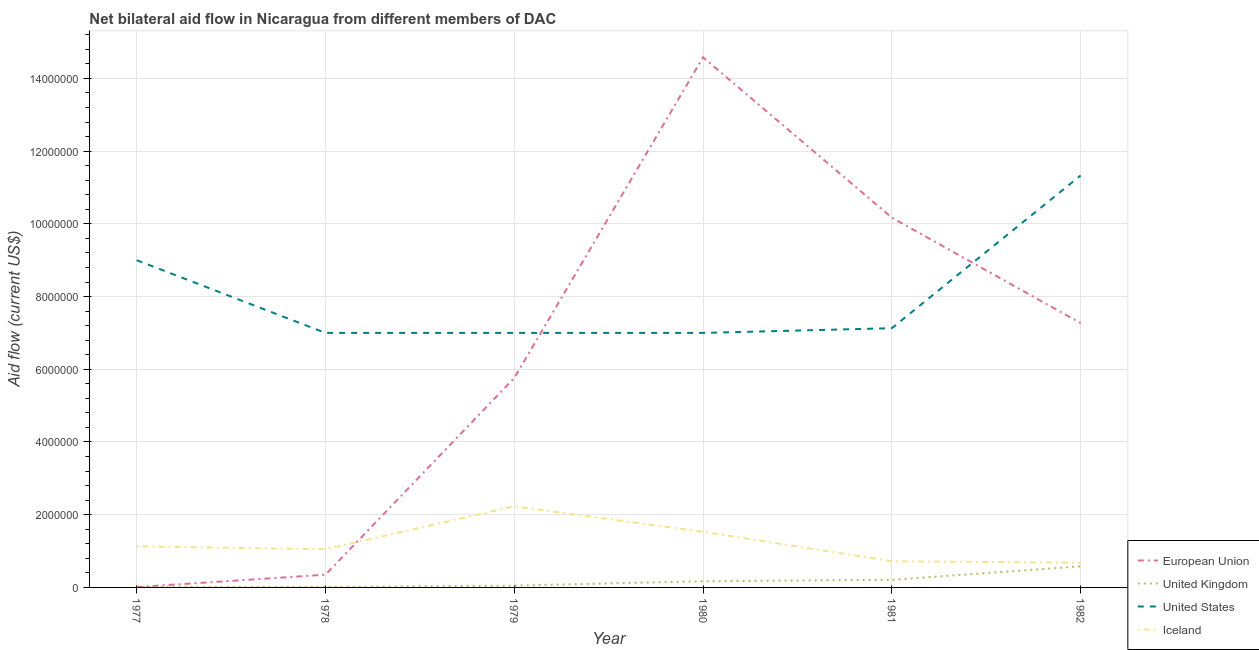How many different coloured lines are there?
Offer a terse response. 4. Does the line corresponding to amount of aid given by eu intersect with the line corresponding to amount of aid given by iceland?
Offer a terse response. Yes. Is the number of lines equal to the number of legend labels?
Provide a succinct answer. Yes. What is the amount of aid given by eu in 1978?
Make the answer very short. 3.50e+05. Across all years, what is the maximum amount of aid given by us?
Offer a terse response. 1.13e+07. Across all years, what is the minimum amount of aid given by iceland?
Offer a terse response. 6.80e+05. In which year was the amount of aid given by us minimum?
Your answer should be very brief. 1978. What is the total amount of aid given by uk in the graph?
Keep it short and to the point. 1.03e+06. What is the difference between the amount of aid given by us in 1978 and that in 1979?
Ensure brevity in your answer.  0. What is the difference between the amount of aid given by eu in 1981 and the amount of aid given by uk in 1982?
Provide a short and direct response. 9.59e+06. What is the average amount of aid given by eu per year?
Offer a terse response. 6.36e+06. What is the ratio of the amount of aid given by uk in 1977 to that in 1982?
Provide a succinct answer. 0.02. Is the amount of aid given by iceland in 1978 less than that in 1979?
Provide a short and direct response. Yes. Is the difference between the amount of aid given by uk in 1980 and 1982 greater than the difference between the amount of aid given by eu in 1980 and 1982?
Your answer should be compact. No. What is the difference between the highest and the second highest amount of aid given by us?
Give a very brief answer. 2.33e+06. What is the difference between the highest and the lowest amount of aid given by eu?
Ensure brevity in your answer.  1.46e+07. In how many years, is the amount of aid given by uk greater than the average amount of aid given by uk taken over all years?
Provide a succinct answer. 2. Is it the case that in every year, the sum of the amount of aid given by iceland and amount of aid given by us is greater than the sum of amount of aid given by eu and amount of aid given by uk?
Provide a short and direct response. No. Is the amount of aid given by us strictly less than the amount of aid given by eu over the years?
Ensure brevity in your answer.  No. How many lines are there?
Offer a very short reply. 4. What is the difference between two consecutive major ticks on the Y-axis?
Offer a terse response. 2.00e+06. Does the graph contain any zero values?
Ensure brevity in your answer.  No. Does the graph contain grids?
Provide a short and direct response. Yes. What is the title of the graph?
Offer a very short reply. Net bilateral aid flow in Nicaragua from different members of DAC. What is the Aid flow (current US$) of European Union in 1977?
Make the answer very short. 10000. What is the Aid flow (current US$) in United States in 1977?
Your response must be concise. 9.00e+06. What is the Aid flow (current US$) of Iceland in 1977?
Ensure brevity in your answer.  1.13e+06. What is the Aid flow (current US$) of European Union in 1978?
Keep it short and to the point. 3.50e+05. What is the Aid flow (current US$) in Iceland in 1978?
Make the answer very short. 1.05e+06. What is the Aid flow (current US$) in European Union in 1979?
Your response must be concise. 5.76e+06. What is the Aid flow (current US$) of United States in 1979?
Provide a short and direct response. 7.00e+06. What is the Aid flow (current US$) of Iceland in 1979?
Your answer should be very brief. 2.23e+06. What is the Aid flow (current US$) in European Union in 1980?
Ensure brevity in your answer.  1.46e+07. What is the Aid flow (current US$) in United Kingdom in 1980?
Ensure brevity in your answer.  1.70e+05. What is the Aid flow (current US$) of United States in 1980?
Offer a very short reply. 7.00e+06. What is the Aid flow (current US$) in Iceland in 1980?
Make the answer very short. 1.53e+06. What is the Aid flow (current US$) of European Union in 1981?
Offer a terse response. 1.02e+07. What is the Aid flow (current US$) in United States in 1981?
Offer a terse response. 7.13e+06. What is the Aid flow (current US$) in Iceland in 1981?
Make the answer very short. 7.20e+05. What is the Aid flow (current US$) of European Union in 1982?
Provide a succinct answer. 7.27e+06. What is the Aid flow (current US$) of United Kingdom in 1982?
Your response must be concise. 5.80e+05. What is the Aid flow (current US$) of United States in 1982?
Your response must be concise. 1.13e+07. What is the Aid flow (current US$) in Iceland in 1982?
Ensure brevity in your answer.  6.80e+05. Across all years, what is the maximum Aid flow (current US$) of European Union?
Your answer should be compact. 1.46e+07. Across all years, what is the maximum Aid flow (current US$) in United Kingdom?
Provide a short and direct response. 5.80e+05. Across all years, what is the maximum Aid flow (current US$) of United States?
Provide a short and direct response. 1.13e+07. Across all years, what is the maximum Aid flow (current US$) in Iceland?
Make the answer very short. 2.23e+06. Across all years, what is the minimum Aid flow (current US$) of United States?
Your answer should be very brief. 7.00e+06. Across all years, what is the minimum Aid flow (current US$) of Iceland?
Keep it short and to the point. 6.80e+05. What is the total Aid flow (current US$) of European Union in the graph?
Your response must be concise. 3.81e+07. What is the total Aid flow (current US$) in United Kingdom in the graph?
Give a very brief answer. 1.03e+06. What is the total Aid flow (current US$) of United States in the graph?
Give a very brief answer. 4.85e+07. What is the total Aid flow (current US$) in Iceland in the graph?
Offer a very short reply. 7.34e+06. What is the difference between the Aid flow (current US$) of European Union in 1977 and that in 1978?
Give a very brief answer. -3.40e+05. What is the difference between the Aid flow (current US$) of United Kingdom in 1977 and that in 1978?
Your answer should be compact. 0. What is the difference between the Aid flow (current US$) of United States in 1977 and that in 1978?
Make the answer very short. 2.00e+06. What is the difference between the Aid flow (current US$) of Iceland in 1977 and that in 1978?
Provide a succinct answer. 8.00e+04. What is the difference between the Aid flow (current US$) in European Union in 1977 and that in 1979?
Provide a short and direct response. -5.75e+06. What is the difference between the Aid flow (current US$) in Iceland in 1977 and that in 1979?
Give a very brief answer. -1.10e+06. What is the difference between the Aid flow (current US$) of European Union in 1977 and that in 1980?
Your response must be concise. -1.46e+07. What is the difference between the Aid flow (current US$) in United Kingdom in 1977 and that in 1980?
Your answer should be very brief. -1.60e+05. What is the difference between the Aid flow (current US$) in Iceland in 1977 and that in 1980?
Ensure brevity in your answer.  -4.00e+05. What is the difference between the Aid flow (current US$) of European Union in 1977 and that in 1981?
Ensure brevity in your answer.  -1.02e+07. What is the difference between the Aid flow (current US$) in United Kingdom in 1977 and that in 1981?
Provide a succinct answer. -2.00e+05. What is the difference between the Aid flow (current US$) of United States in 1977 and that in 1981?
Your response must be concise. 1.87e+06. What is the difference between the Aid flow (current US$) in European Union in 1977 and that in 1982?
Offer a very short reply. -7.26e+06. What is the difference between the Aid flow (current US$) of United Kingdom in 1977 and that in 1982?
Offer a terse response. -5.70e+05. What is the difference between the Aid flow (current US$) of United States in 1977 and that in 1982?
Provide a short and direct response. -2.33e+06. What is the difference between the Aid flow (current US$) of Iceland in 1977 and that in 1982?
Make the answer very short. 4.50e+05. What is the difference between the Aid flow (current US$) in European Union in 1978 and that in 1979?
Your answer should be compact. -5.41e+06. What is the difference between the Aid flow (current US$) of United Kingdom in 1978 and that in 1979?
Keep it short and to the point. -4.00e+04. What is the difference between the Aid flow (current US$) in Iceland in 1978 and that in 1979?
Your response must be concise. -1.18e+06. What is the difference between the Aid flow (current US$) in European Union in 1978 and that in 1980?
Your response must be concise. -1.42e+07. What is the difference between the Aid flow (current US$) in United Kingdom in 1978 and that in 1980?
Offer a very short reply. -1.60e+05. What is the difference between the Aid flow (current US$) of Iceland in 1978 and that in 1980?
Give a very brief answer. -4.80e+05. What is the difference between the Aid flow (current US$) in European Union in 1978 and that in 1981?
Ensure brevity in your answer.  -9.82e+06. What is the difference between the Aid flow (current US$) of European Union in 1978 and that in 1982?
Your response must be concise. -6.92e+06. What is the difference between the Aid flow (current US$) in United Kingdom in 1978 and that in 1982?
Make the answer very short. -5.70e+05. What is the difference between the Aid flow (current US$) in United States in 1978 and that in 1982?
Your answer should be very brief. -4.33e+06. What is the difference between the Aid flow (current US$) of Iceland in 1978 and that in 1982?
Your answer should be very brief. 3.70e+05. What is the difference between the Aid flow (current US$) in European Union in 1979 and that in 1980?
Your answer should be very brief. -8.82e+06. What is the difference between the Aid flow (current US$) in European Union in 1979 and that in 1981?
Keep it short and to the point. -4.41e+06. What is the difference between the Aid flow (current US$) of Iceland in 1979 and that in 1981?
Provide a succinct answer. 1.51e+06. What is the difference between the Aid flow (current US$) in European Union in 1979 and that in 1982?
Your response must be concise. -1.51e+06. What is the difference between the Aid flow (current US$) of United Kingdom in 1979 and that in 1982?
Provide a short and direct response. -5.30e+05. What is the difference between the Aid flow (current US$) of United States in 1979 and that in 1982?
Keep it short and to the point. -4.33e+06. What is the difference between the Aid flow (current US$) of Iceland in 1979 and that in 1982?
Give a very brief answer. 1.55e+06. What is the difference between the Aid flow (current US$) of European Union in 1980 and that in 1981?
Your answer should be compact. 4.41e+06. What is the difference between the Aid flow (current US$) of United States in 1980 and that in 1981?
Offer a very short reply. -1.30e+05. What is the difference between the Aid flow (current US$) of Iceland in 1980 and that in 1981?
Offer a terse response. 8.10e+05. What is the difference between the Aid flow (current US$) in European Union in 1980 and that in 1982?
Provide a succinct answer. 7.31e+06. What is the difference between the Aid flow (current US$) in United Kingdom in 1980 and that in 1982?
Provide a short and direct response. -4.10e+05. What is the difference between the Aid flow (current US$) in United States in 1980 and that in 1982?
Provide a succinct answer. -4.33e+06. What is the difference between the Aid flow (current US$) of Iceland in 1980 and that in 1982?
Provide a succinct answer. 8.50e+05. What is the difference between the Aid flow (current US$) of European Union in 1981 and that in 1982?
Offer a very short reply. 2.90e+06. What is the difference between the Aid flow (current US$) in United Kingdom in 1981 and that in 1982?
Your answer should be compact. -3.70e+05. What is the difference between the Aid flow (current US$) in United States in 1981 and that in 1982?
Keep it short and to the point. -4.20e+06. What is the difference between the Aid flow (current US$) of European Union in 1977 and the Aid flow (current US$) of United States in 1978?
Provide a short and direct response. -6.99e+06. What is the difference between the Aid flow (current US$) of European Union in 1977 and the Aid flow (current US$) of Iceland in 1978?
Keep it short and to the point. -1.04e+06. What is the difference between the Aid flow (current US$) in United Kingdom in 1977 and the Aid flow (current US$) in United States in 1978?
Provide a succinct answer. -6.99e+06. What is the difference between the Aid flow (current US$) of United Kingdom in 1977 and the Aid flow (current US$) of Iceland in 1978?
Your response must be concise. -1.04e+06. What is the difference between the Aid flow (current US$) in United States in 1977 and the Aid flow (current US$) in Iceland in 1978?
Offer a very short reply. 7.95e+06. What is the difference between the Aid flow (current US$) of European Union in 1977 and the Aid flow (current US$) of United States in 1979?
Provide a short and direct response. -6.99e+06. What is the difference between the Aid flow (current US$) in European Union in 1977 and the Aid flow (current US$) in Iceland in 1979?
Provide a succinct answer. -2.22e+06. What is the difference between the Aid flow (current US$) in United Kingdom in 1977 and the Aid flow (current US$) in United States in 1979?
Give a very brief answer. -6.99e+06. What is the difference between the Aid flow (current US$) of United Kingdom in 1977 and the Aid flow (current US$) of Iceland in 1979?
Offer a terse response. -2.22e+06. What is the difference between the Aid flow (current US$) of United States in 1977 and the Aid flow (current US$) of Iceland in 1979?
Keep it short and to the point. 6.77e+06. What is the difference between the Aid flow (current US$) of European Union in 1977 and the Aid flow (current US$) of United Kingdom in 1980?
Your answer should be compact. -1.60e+05. What is the difference between the Aid flow (current US$) in European Union in 1977 and the Aid flow (current US$) in United States in 1980?
Your answer should be compact. -6.99e+06. What is the difference between the Aid flow (current US$) in European Union in 1977 and the Aid flow (current US$) in Iceland in 1980?
Your answer should be very brief. -1.52e+06. What is the difference between the Aid flow (current US$) in United Kingdom in 1977 and the Aid flow (current US$) in United States in 1980?
Provide a succinct answer. -6.99e+06. What is the difference between the Aid flow (current US$) of United Kingdom in 1977 and the Aid flow (current US$) of Iceland in 1980?
Your answer should be compact. -1.52e+06. What is the difference between the Aid flow (current US$) in United States in 1977 and the Aid flow (current US$) in Iceland in 1980?
Offer a terse response. 7.47e+06. What is the difference between the Aid flow (current US$) in European Union in 1977 and the Aid flow (current US$) in United States in 1981?
Offer a terse response. -7.12e+06. What is the difference between the Aid flow (current US$) of European Union in 1977 and the Aid flow (current US$) of Iceland in 1981?
Offer a very short reply. -7.10e+05. What is the difference between the Aid flow (current US$) in United Kingdom in 1977 and the Aid flow (current US$) in United States in 1981?
Provide a succinct answer. -7.12e+06. What is the difference between the Aid flow (current US$) in United Kingdom in 1977 and the Aid flow (current US$) in Iceland in 1981?
Ensure brevity in your answer.  -7.10e+05. What is the difference between the Aid flow (current US$) of United States in 1977 and the Aid flow (current US$) of Iceland in 1981?
Provide a short and direct response. 8.28e+06. What is the difference between the Aid flow (current US$) in European Union in 1977 and the Aid flow (current US$) in United Kingdom in 1982?
Keep it short and to the point. -5.70e+05. What is the difference between the Aid flow (current US$) of European Union in 1977 and the Aid flow (current US$) of United States in 1982?
Give a very brief answer. -1.13e+07. What is the difference between the Aid flow (current US$) of European Union in 1977 and the Aid flow (current US$) of Iceland in 1982?
Your response must be concise. -6.70e+05. What is the difference between the Aid flow (current US$) of United Kingdom in 1977 and the Aid flow (current US$) of United States in 1982?
Ensure brevity in your answer.  -1.13e+07. What is the difference between the Aid flow (current US$) of United Kingdom in 1977 and the Aid flow (current US$) of Iceland in 1982?
Your answer should be very brief. -6.70e+05. What is the difference between the Aid flow (current US$) of United States in 1977 and the Aid flow (current US$) of Iceland in 1982?
Ensure brevity in your answer.  8.32e+06. What is the difference between the Aid flow (current US$) of European Union in 1978 and the Aid flow (current US$) of United Kingdom in 1979?
Provide a succinct answer. 3.00e+05. What is the difference between the Aid flow (current US$) in European Union in 1978 and the Aid flow (current US$) in United States in 1979?
Offer a terse response. -6.65e+06. What is the difference between the Aid flow (current US$) in European Union in 1978 and the Aid flow (current US$) in Iceland in 1979?
Your answer should be compact. -1.88e+06. What is the difference between the Aid flow (current US$) in United Kingdom in 1978 and the Aid flow (current US$) in United States in 1979?
Provide a succinct answer. -6.99e+06. What is the difference between the Aid flow (current US$) in United Kingdom in 1978 and the Aid flow (current US$) in Iceland in 1979?
Provide a succinct answer. -2.22e+06. What is the difference between the Aid flow (current US$) in United States in 1978 and the Aid flow (current US$) in Iceland in 1979?
Your answer should be compact. 4.77e+06. What is the difference between the Aid flow (current US$) in European Union in 1978 and the Aid flow (current US$) in United Kingdom in 1980?
Keep it short and to the point. 1.80e+05. What is the difference between the Aid flow (current US$) in European Union in 1978 and the Aid flow (current US$) in United States in 1980?
Offer a terse response. -6.65e+06. What is the difference between the Aid flow (current US$) of European Union in 1978 and the Aid flow (current US$) of Iceland in 1980?
Provide a short and direct response. -1.18e+06. What is the difference between the Aid flow (current US$) in United Kingdom in 1978 and the Aid flow (current US$) in United States in 1980?
Ensure brevity in your answer.  -6.99e+06. What is the difference between the Aid flow (current US$) of United Kingdom in 1978 and the Aid flow (current US$) of Iceland in 1980?
Your answer should be compact. -1.52e+06. What is the difference between the Aid flow (current US$) of United States in 1978 and the Aid flow (current US$) of Iceland in 1980?
Ensure brevity in your answer.  5.47e+06. What is the difference between the Aid flow (current US$) in European Union in 1978 and the Aid flow (current US$) in United Kingdom in 1981?
Make the answer very short. 1.40e+05. What is the difference between the Aid flow (current US$) of European Union in 1978 and the Aid flow (current US$) of United States in 1981?
Provide a short and direct response. -6.78e+06. What is the difference between the Aid flow (current US$) of European Union in 1978 and the Aid flow (current US$) of Iceland in 1981?
Your response must be concise. -3.70e+05. What is the difference between the Aid flow (current US$) of United Kingdom in 1978 and the Aid flow (current US$) of United States in 1981?
Your answer should be compact. -7.12e+06. What is the difference between the Aid flow (current US$) in United Kingdom in 1978 and the Aid flow (current US$) in Iceland in 1981?
Make the answer very short. -7.10e+05. What is the difference between the Aid flow (current US$) of United States in 1978 and the Aid flow (current US$) of Iceland in 1981?
Keep it short and to the point. 6.28e+06. What is the difference between the Aid flow (current US$) in European Union in 1978 and the Aid flow (current US$) in United States in 1982?
Your answer should be compact. -1.10e+07. What is the difference between the Aid flow (current US$) in European Union in 1978 and the Aid flow (current US$) in Iceland in 1982?
Offer a terse response. -3.30e+05. What is the difference between the Aid flow (current US$) of United Kingdom in 1978 and the Aid flow (current US$) of United States in 1982?
Ensure brevity in your answer.  -1.13e+07. What is the difference between the Aid flow (current US$) in United Kingdom in 1978 and the Aid flow (current US$) in Iceland in 1982?
Offer a terse response. -6.70e+05. What is the difference between the Aid flow (current US$) of United States in 1978 and the Aid flow (current US$) of Iceland in 1982?
Make the answer very short. 6.32e+06. What is the difference between the Aid flow (current US$) in European Union in 1979 and the Aid flow (current US$) in United Kingdom in 1980?
Provide a succinct answer. 5.59e+06. What is the difference between the Aid flow (current US$) of European Union in 1979 and the Aid flow (current US$) of United States in 1980?
Make the answer very short. -1.24e+06. What is the difference between the Aid flow (current US$) in European Union in 1979 and the Aid flow (current US$) in Iceland in 1980?
Make the answer very short. 4.23e+06. What is the difference between the Aid flow (current US$) in United Kingdom in 1979 and the Aid flow (current US$) in United States in 1980?
Provide a short and direct response. -6.95e+06. What is the difference between the Aid flow (current US$) of United Kingdom in 1979 and the Aid flow (current US$) of Iceland in 1980?
Your response must be concise. -1.48e+06. What is the difference between the Aid flow (current US$) of United States in 1979 and the Aid flow (current US$) of Iceland in 1980?
Offer a very short reply. 5.47e+06. What is the difference between the Aid flow (current US$) in European Union in 1979 and the Aid flow (current US$) in United Kingdom in 1981?
Your response must be concise. 5.55e+06. What is the difference between the Aid flow (current US$) of European Union in 1979 and the Aid flow (current US$) of United States in 1981?
Provide a succinct answer. -1.37e+06. What is the difference between the Aid flow (current US$) in European Union in 1979 and the Aid flow (current US$) in Iceland in 1981?
Make the answer very short. 5.04e+06. What is the difference between the Aid flow (current US$) in United Kingdom in 1979 and the Aid flow (current US$) in United States in 1981?
Keep it short and to the point. -7.08e+06. What is the difference between the Aid flow (current US$) in United Kingdom in 1979 and the Aid flow (current US$) in Iceland in 1981?
Your response must be concise. -6.70e+05. What is the difference between the Aid flow (current US$) of United States in 1979 and the Aid flow (current US$) of Iceland in 1981?
Your response must be concise. 6.28e+06. What is the difference between the Aid flow (current US$) in European Union in 1979 and the Aid flow (current US$) in United Kingdom in 1982?
Offer a terse response. 5.18e+06. What is the difference between the Aid flow (current US$) of European Union in 1979 and the Aid flow (current US$) of United States in 1982?
Provide a succinct answer. -5.57e+06. What is the difference between the Aid flow (current US$) in European Union in 1979 and the Aid flow (current US$) in Iceland in 1982?
Give a very brief answer. 5.08e+06. What is the difference between the Aid flow (current US$) of United Kingdom in 1979 and the Aid flow (current US$) of United States in 1982?
Offer a terse response. -1.13e+07. What is the difference between the Aid flow (current US$) in United Kingdom in 1979 and the Aid flow (current US$) in Iceland in 1982?
Give a very brief answer. -6.30e+05. What is the difference between the Aid flow (current US$) of United States in 1979 and the Aid flow (current US$) of Iceland in 1982?
Ensure brevity in your answer.  6.32e+06. What is the difference between the Aid flow (current US$) in European Union in 1980 and the Aid flow (current US$) in United Kingdom in 1981?
Ensure brevity in your answer.  1.44e+07. What is the difference between the Aid flow (current US$) in European Union in 1980 and the Aid flow (current US$) in United States in 1981?
Provide a short and direct response. 7.45e+06. What is the difference between the Aid flow (current US$) of European Union in 1980 and the Aid flow (current US$) of Iceland in 1981?
Your answer should be compact. 1.39e+07. What is the difference between the Aid flow (current US$) of United Kingdom in 1980 and the Aid flow (current US$) of United States in 1981?
Ensure brevity in your answer.  -6.96e+06. What is the difference between the Aid flow (current US$) in United Kingdom in 1980 and the Aid flow (current US$) in Iceland in 1981?
Keep it short and to the point. -5.50e+05. What is the difference between the Aid flow (current US$) in United States in 1980 and the Aid flow (current US$) in Iceland in 1981?
Keep it short and to the point. 6.28e+06. What is the difference between the Aid flow (current US$) in European Union in 1980 and the Aid flow (current US$) in United Kingdom in 1982?
Ensure brevity in your answer.  1.40e+07. What is the difference between the Aid flow (current US$) of European Union in 1980 and the Aid flow (current US$) of United States in 1982?
Your answer should be compact. 3.25e+06. What is the difference between the Aid flow (current US$) of European Union in 1980 and the Aid flow (current US$) of Iceland in 1982?
Your response must be concise. 1.39e+07. What is the difference between the Aid flow (current US$) in United Kingdom in 1980 and the Aid flow (current US$) in United States in 1982?
Make the answer very short. -1.12e+07. What is the difference between the Aid flow (current US$) of United Kingdom in 1980 and the Aid flow (current US$) of Iceland in 1982?
Your answer should be very brief. -5.10e+05. What is the difference between the Aid flow (current US$) in United States in 1980 and the Aid flow (current US$) in Iceland in 1982?
Provide a short and direct response. 6.32e+06. What is the difference between the Aid flow (current US$) in European Union in 1981 and the Aid flow (current US$) in United Kingdom in 1982?
Your answer should be very brief. 9.59e+06. What is the difference between the Aid flow (current US$) of European Union in 1981 and the Aid flow (current US$) of United States in 1982?
Ensure brevity in your answer.  -1.16e+06. What is the difference between the Aid flow (current US$) of European Union in 1981 and the Aid flow (current US$) of Iceland in 1982?
Make the answer very short. 9.49e+06. What is the difference between the Aid flow (current US$) of United Kingdom in 1981 and the Aid flow (current US$) of United States in 1982?
Your answer should be compact. -1.11e+07. What is the difference between the Aid flow (current US$) in United Kingdom in 1981 and the Aid flow (current US$) in Iceland in 1982?
Provide a succinct answer. -4.70e+05. What is the difference between the Aid flow (current US$) in United States in 1981 and the Aid flow (current US$) in Iceland in 1982?
Your answer should be very brief. 6.45e+06. What is the average Aid flow (current US$) in European Union per year?
Give a very brief answer. 6.36e+06. What is the average Aid flow (current US$) of United Kingdom per year?
Your answer should be very brief. 1.72e+05. What is the average Aid flow (current US$) in United States per year?
Offer a terse response. 8.08e+06. What is the average Aid flow (current US$) in Iceland per year?
Make the answer very short. 1.22e+06. In the year 1977, what is the difference between the Aid flow (current US$) in European Union and Aid flow (current US$) in United States?
Keep it short and to the point. -8.99e+06. In the year 1977, what is the difference between the Aid flow (current US$) in European Union and Aid flow (current US$) in Iceland?
Give a very brief answer. -1.12e+06. In the year 1977, what is the difference between the Aid flow (current US$) in United Kingdom and Aid flow (current US$) in United States?
Make the answer very short. -8.99e+06. In the year 1977, what is the difference between the Aid flow (current US$) in United Kingdom and Aid flow (current US$) in Iceland?
Offer a very short reply. -1.12e+06. In the year 1977, what is the difference between the Aid flow (current US$) of United States and Aid flow (current US$) of Iceland?
Your answer should be very brief. 7.87e+06. In the year 1978, what is the difference between the Aid flow (current US$) of European Union and Aid flow (current US$) of United Kingdom?
Provide a short and direct response. 3.40e+05. In the year 1978, what is the difference between the Aid flow (current US$) of European Union and Aid flow (current US$) of United States?
Your answer should be compact. -6.65e+06. In the year 1978, what is the difference between the Aid flow (current US$) in European Union and Aid flow (current US$) in Iceland?
Offer a very short reply. -7.00e+05. In the year 1978, what is the difference between the Aid flow (current US$) of United Kingdom and Aid flow (current US$) of United States?
Your answer should be compact. -6.99e+06. In the year 1978, what is the difference between the Aid flow (current US$) of United Kingdom and Aid flow (current US$) of Iceland?
Your response must be concise. -1.04e+06. In the year 1978, what is the difference between the Aid flow (current US$) of United States and Aid flow (current US$) of Iceland?
Provide a succinct answer. 5.95e+06. In the year 1979, what is the difference between the Aid flow (current US$) of European Union and Aid flow (current US$) of United Kingdom?
Offer a terse response. 5.71e+06. In the year 1979, what is the difference between the Aid flow (current US$) in European Union and Aid flow (current US$) in United States?
Provide a short and direct response. -1.24e+06. In the year 1979, what is the difference between the Aid flow (current US$) of European Union and Aid flow (current US$) of Iceland?
Offer a terse response. 3.53e+06. In the year 1979, what is the difference between the Aid flow (current US$) in United Kingdom and Aid flow (current US$) in United States?
Give a very brief answer. -6.95e+06. In the year 1979, what is the difference between the Aid flow (current US$) in United Kingdom and Aid flow (current US$) in Iceland?
Your response must be concise. -2.18e+06. In the year 1979, what is the difference between the Aid flow (current US$) of United States and Aid flow (current US$) of Iceland?
Your answer should be compact. 4.77e+06. In the year 1980, what is the difference between the Aid flow (current US$) in European Union and Aid flow (current US$) in United Kingdom?
Keep it short and to the point. 1.44e+07. In the year 1980, what is the difference between the Aid flow (current US$) in European Union and Aid flow (current US$) in United States?
Your response must be concise. 7.58e+06. In the year 1980, what is the difference between the Aid flow (current US$) of European Union and Aid flow (current US$) of Iceland?
Give a very brief answer. 1.30e+07. In the year 1980, what is the difference between the Aid flow (current US$) of United Kingdom and Aid flow (current US$) of United States?
Your answer should be very brief. -6.83e+06. In the year 1980, what is the difference between the Aid flow (current US$) of United Kingdom and Aid flow (current US$) of Iceland?
Your answer should be very brief. -1.36e+06. In the year 1980, what is the difference between the Aid flow (current US$) in United States and Aid flow (current US$) in Iceland?
Give a very brief answer. 5.47e+06. In the year 1981, what is the difference between the Aid flow (current US$) of European Union and Aid flow (current US$) of United Kingdom?
Give a very brief answer. 9.96e+06. In the year 1981, what is the difference between the Aid flow (current US$) in European Union and Aid flow (current US$) in United States?
Ensure brevity in your answer.  3.04e+06. In the year 1981, what is the difference between the Aid flow (current US$) of European Union and Aid flow (current US$) of Iceland?
Make the answer very short. 9.45e+06. In the year 1981, what is the difference between the Aid flow (current US$) in United Kingdom and Aid flow (current US$) in United States?
Your response must be concise. -6.92e+06. In the year 1981, what is the difference between the Aid flow (current US$) of United Kingdom and Aid flow (current US$) of Iceland?
Offer a very short reply. -5.10e+05. In the year 1981, what is the difference between the Aid flow (current US$) in United States and Aid flow (current US$) in Iceland?
Your answer should be very brief. 6.41e+06. In the year 1982, what is the difference between the Aid flow (current US$) in European Union and Aid flow (current US$) in United Kingdom?
Provide a short and direct response. 6.69e+06. In the year 1982, what is the difference between the Aid flow (current US$) of European Union and Aid flow (current US$) of United States?
Provide a succinct answer. -4.06e+06. In the year 1982, what is the difference between the Aid flow (current US$) of European Union and Aid flow (current US$) of Iceland?
Ensure brevity in your answer.  6.59e+06. In the year 1982, what is the difference between the Aid flow (current US$) of United Kingdom and Aid flow (current US$) of United States?
Offer a very short reply. -1.08e+07. In the year 1982, what is the difference between the Aid flow (current US$) in United States and Aid flow (current US$) in Iceland?
Your answer should be very brief. 1.06e+07. What is the ratio of the Aid flow (current US$) of European Union in 1977 to that in 1978?
Your answer should be very brief. 0.03. What is the ratio of the Aid flow (current US$) in Iceland in 1977 to that in 1978?
Offer a terse response. 1.08. What is the ratio of the Aid flow (current US$) in European Union in 1977 to that in 1979?
Give a very brief answer. 0. What is the ratio of the Aid flow (current US$) in United Kingdom in 1977 to that in 1979?
Your answer should be very brief. 0.2. What is the ratio of the Aid flow (current US$) in United States in 1977 to that in 1979?
Give a very brief answer. 1.29. What is the ratio of the Aid flow (current US$) in Iceland in 1977 to that in 1979?
Your answer should be very brief. 0.51. What is the ratio of the Aid flow (current US$) in European Union in 1977 to that in 1980?
Give a very brief answer. 0. What is the ratio of the Aid flow (current US$) of United Kingdom in 1977 to that in 1980?
Offer a very short reply. 0.06. What is the ratio of the Aid flow (current US$) in United States in 1977 to that in 1980?
Give a very brief answer. 1.29. What is the ratio of the Aid flow (current US$) in Iceland in 1977 to that in 1980?
Make the answer very short. 0.74. What is the ratio of the Aid flow (current US$) in United Kingdom in 1977 to that in 1981?
Ensure brevity in your answer.  0.05. What is the ratio of the Aid flow (current US$) of United States in 1977 to that in 1981?
Provide a short and direct response. 1.26. What is the ratio of the Aid flow (current US$) in Iceland in 1977 to that in 1981?
Your answer should be very brief. 1.57. What is the ratio of the Aid flow (current US$) in European Union in 1977 to that in 1982?
Offer a terse response. 0. What is the ratio of the Aid flow (current US$) in United Kingdom in 1977 to that in 1982?
Provide a succinct answer. 0.02. What is the ratio of the Aid flow (current US$) of United States in 1977 to that in 1982?
Provide a succinct answer. 0.79. What is the ratio of the Aid flow (current US$) of Iceland in 1977 to that in 1982?
Keep it short and to the point. 1.66. What is the ratio of the Aid flow (current US$) of European Union in 1978 to that in 1979?
Ensure brevity in your answer.  0.06. What is the ratio of the Aid flow (current US$) of United Kingdom in 1978 to that in 1979?
Your answer should be very brief. 0.2. What is the ratio of the Aid flow (current US$) in Iceland in 1978 to that in 1979?
Offer a terse response. 0.47. What is the ratio of the Aid flow (current US$) in European Union in 1978 to that in 1980?
Keep it short and to the point. 0.02. What is the ratio of the Aid flow (current US$) in United Kingdom in 1978 to that in 1980?
Your answer should be very brief. 0.06. What is the ratio of the Aid flow (current US$) in United States in 1978 to that in 1980?
Offer a very short reply. 1. What is the ratio of the Aid flow (current US$) of Iceland in 1978 to that in 1980?
Your response must be concise. 0.69. What is the ratio of the Aid flow (current US$) in European Union in 1978 to that in 1981?
Ensure brevity in your answer.  0.03. What is the ratio of the Aid flow (current US$) of United Kingdom in 1978 to that in 1981?
Give a very brief answer. 0.05. What is the ratio of the Aid flow (current US$) in United States in 1978 to that in 1981?
Provide a succinct answer. 0.98. What is the ratio of the Aid flow (current US$) of Iceland in 1978 to that in 1981?
Give a very brief answer. 1.46. What is the ratio of the Aid flow (current US$) of European Union in 1978 to that in 1982?
Offer a terse response. 0.05. What is the ratio of the Aid flow (current US$) of United Kingdom in 1978 to that in 1982?
Give a very brief answer. 0.02. What is the ratio of the Aid flow (current US$) in United States in 1978 to that in 1982?
Offer a very short reply. 0.62. What is the ratio of the Aid flow (current US$) of Iceland in 1978 to that in 1982?
Your answer should be very brief. 1.54. What is the ratio of the Aid flow (current US$) of European Union in 1979 to that in 1980?
Keep it short and to the point. 0.4. What is the ratio of the Aid flow (current US$) of United Kingdom in 1979 to that in 1980?
Keep it short and to the point. 0.29. What is the ratio of the Aid flow (current US$) of United States in 1979 to that in 1980?
Your answer should be very brief. 1. What is the ratio of the Aid flow (current US$) of Iceland in 1979 to that in 1980?
Your response must be concise. 1.46. What is the ratio of the Aid flow (current US$) in European Union in 1979 to that in 1981?
Offer a terse response. 0.57. What is the ratio of the Aid flow (current US$) in United Kingdom in 1979 to that in 1981?
Your answer should be compact. 0.24. What is the ratio of the Aid flow (current US$) in United States in 1979 to that in 1981?
Offer a very short reply. 0.98. What is the ratio of the Aid flow (current US$) in Iceland in 1979 to that in 1981?
Ensure brevity in your answer.  3.1. What is the ratio of the Aid flow (current US$) of European Union in 1979 to that in 1982?
Offer a very short reply. 0.79. What is the ratio of the Aid flow (current US$) in United Kingdom in 1979 to that in 1982?
Offer a very short reply. 0.09. What is the ratio of the Aid flow (current US$) of United States in 1979 to that in 1982?
Provide a succinct answer. 0.62. What is the ratio of the Aid flow (current US$) of Iceland in 1979 to that in 1982?
Make the answer very short. 3.28. What is the ratio of the Aid flow (current US$) in European Union in 1980 to that in 1981?
Your answer should be very brief. 1.43. What is the ratio of the Aid flow (current US$) of United Kingdom in 1980 to that in 1981?
Offer a terse response. 0.81. What is the ratio of the Aid flow (current US$) in United States in 1980 to that in 1981?
Ensure brevity in your answer.  0.98. What is the ratio of the Aid flow (current US$) of Iceland in 1980 to that in 1981?
Your answer should be very brief. 2.12. What is the ratio of the Aid flow (current US$) in European Union in 1980 to that in 1982?
Offer a very short reply. 2.01. What is the ratio of the Aid flow (current US$) of United Kingdom in 1980 to that in 1982?
Keep it short and to the point. 0.29. What is the ratio of the Aid flow (current US$) of United States in 1980 to that in 1982?
Your response must be concise. 0.62. What is the ratio of the Aid flow (current US$) of Iceland in 1980 to that in 1982?
Your response must be concise. 2.25. What is the ratio of the Aid flow (current US$) in European Union in 1981 to that in 1982?
Make the answer very short. 1.4. What is the ratio of the Aid flow (current US$) in United Kingdom in 1981 to that in 1982?
Provide a short and direct response. 0.36. What is the ratio of the Aid flow (current US$) of United States in 1981 to that in 1982?
Provide a short and direct response. 0.63. What is the ratio of the Aid flow (current US$) of Iceland in 1981 to that in 1982?
Offer a terse response. 1.06. What is the difference between the highest and the second highest Aid flow (current US$) in European Union?
Ensure brevity in your answer.  4.41e+06. What is the difference between the highest and the second highest Aid flow (current US$) of United Kingdom?
Provide a succinct answer. 3.70e+05. What is the difference between the highest and the second highest Aid flow (current US$) of United States?
Offer a terse response. 2.33e+06. What is the difference between the highest and the second highest Aid flow (current US$) of Iceland?
Offer a terse response. 7.00e+05. What is the difference between the highest and the lowest Aid flow (current US$) of European Union?
Your answer should be very brief. 1.46e+07. What is the difference between the highest and the lowest Aid flow (current US$) in United Kingdom?
Keep it short and to the point. 5.70e+05. What is the difference between the highest and the lowest Aid flow (current US$) in United States?
Give a very brief answer. 4.33e+06. What is the difference between the highest and the lowest Aid flow (current US$) in Iceland?
Offer a very short reply. 1.55e+06. 